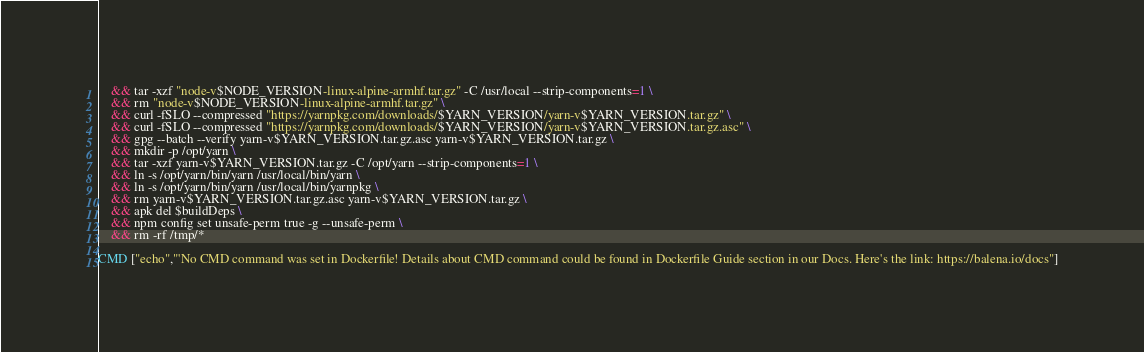Convert code to text. <code><loc_0><loc_0><loc_500><loc_500><_Dockerfile_>	&& tar -xzf "node-v$NODE_VERSION-linux-alpine-armhf.tar.gz" -C /usr/local --strip-components=1 \
	&& rm "node-v$NODE_VERSION-linux-alpine-armhf.tar.gz" \
	&& curl -fSLO --compressed "https://yarnpkg.com/downloads/$YARN_VERSION/yarn-v$YARN_VERSION.tar.gz" \
	&& curl -fSLO --compressed "https://yarnpkg.com/downloads/$YARN_VERSION/yarn-v$YARN_VERSION.tar.gz.asc" \
	&& gpg --batch --verify yarn-v$YARN_VERSION.tar.gz.asc yarn-v$YARN_VERSION.tar.gz \
	&& mkdir -p /opt/yarn \
	&& tar -xzf yarn-v$YARN_VERSION.tar.gz -C /opt/yarn --strip-components=1 \
	&& ln -s /opt/yarn/bin/yarn /usr/local/bin/yarn \
	&& ln -s /opt/yarn/bin/yarn /usr/local/bin/yarnpkg \
	&& rm yarn-v$YARN_VERSION.tar.gz.asc yarn-v$YARN_VERSION.tar.gz \
	&& apk del $buildDeps \
	&& npm config set unsafe-perm true -g --unsafe-perm \
	&& rm -rf /tmp/*

CMD ["echo","'No CMD command was set in Dockerfile! Details about CMD command could be found in Dockerfile Guide section in our Docs. Here's the link: https://balena.io/docs"]</code> 